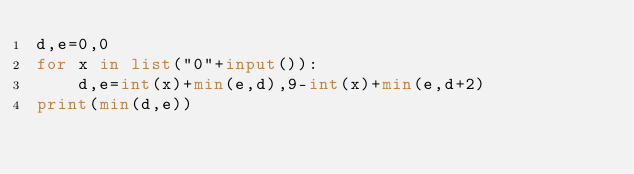<code> <loc_0><loc_0><loc_500><loc_500><_Python_>d,e=0,0
for x in list("0"+input()):
	d,e=int(x)+min(e,d),9-int(x)+min(e,d+2)
print(min(d,e))</code> 